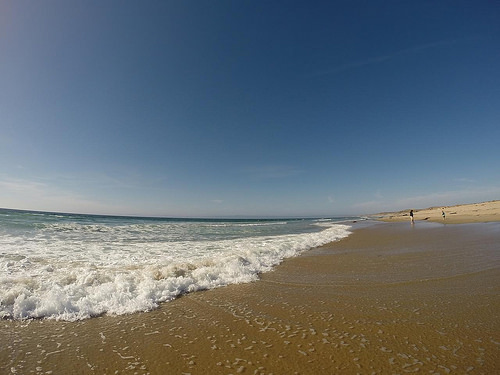<image>
Is there a beach in front of the sea water? Yes. The beach is positioned in front of the sea water, appearing closer to the camera viewpoint. 